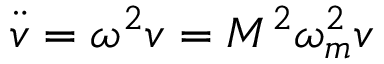<formula> <loc_0><loc_0><loc_500><loc_500>\ddot { v } = \omega ^ { 2 } v = M ^ { 2 } \omega _ { m } ^ { 2 } v</formula> 